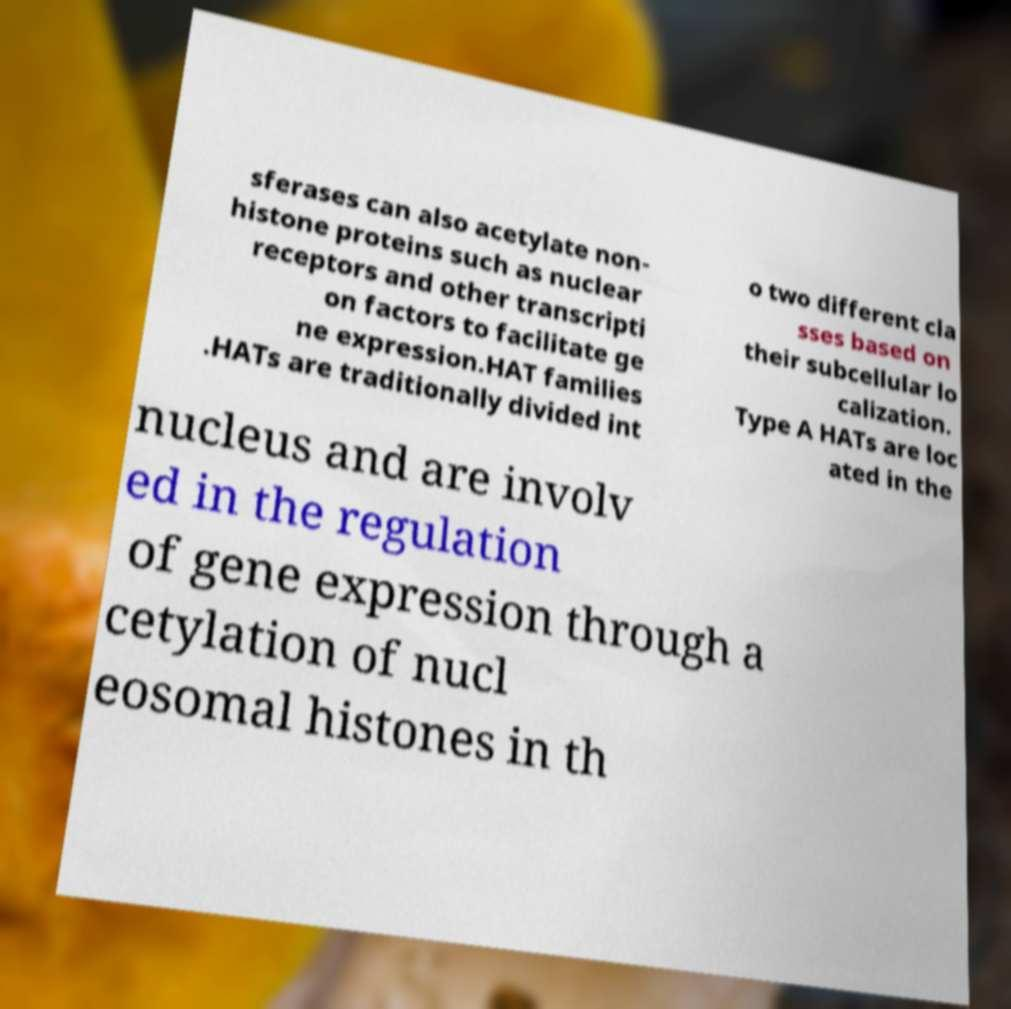Can you accurately transcribe the text from the provided image for me? sferases can also acetylate non- histone proteins such as nuclear receptors and other transcripti on factors to facilitate ge ne expression.HAT families .HATs are traditionally divided int o two different cla sses based on their subcellular lo calization. Type A HATs are loc ated in the nucleus and are involv ed in the regulation of gene expression through a cetylation of nucl eosomal histones in th 